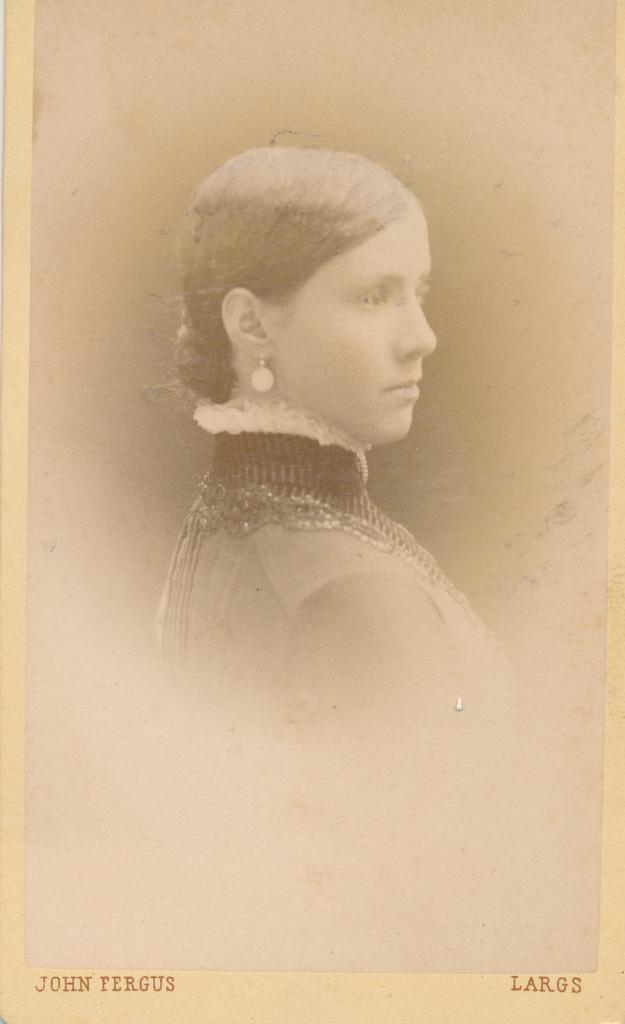How would you summarize this image in a sentence or two? In this picture we can see a photograph of a person, at the bottom there is some text. 